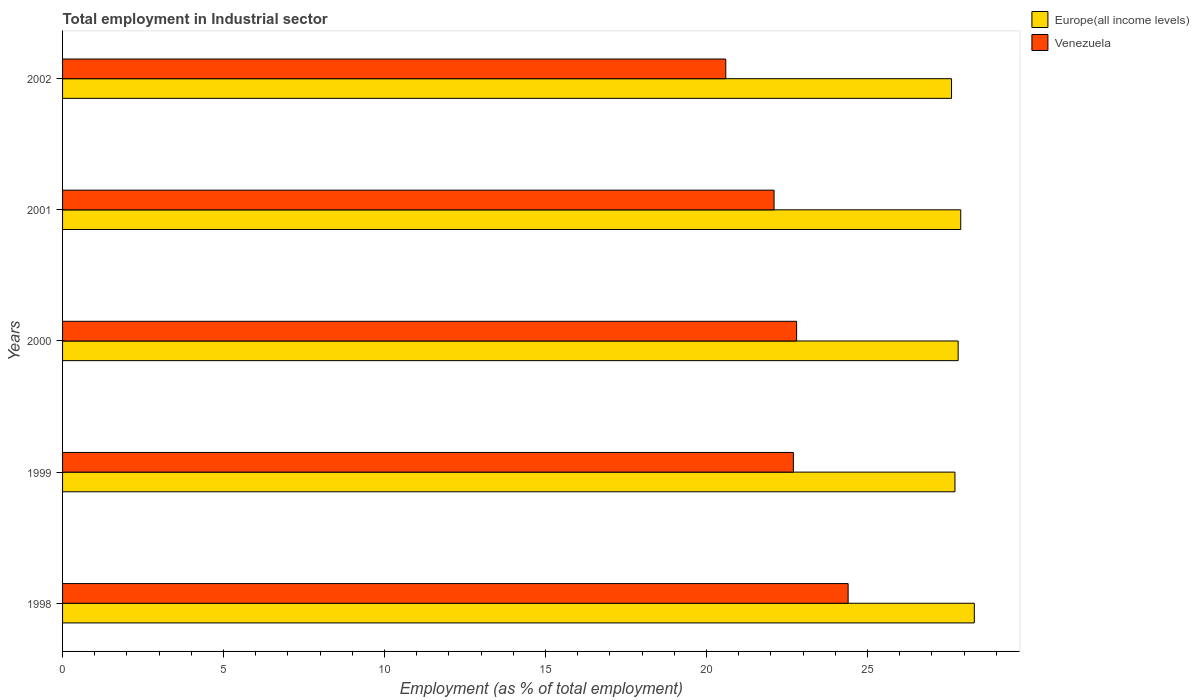Are the number of bars per tick equal to the number of legend labels?
Give a very brief answer. Yes. Are the number of bars on each tick of the Y-axis equal?
Your answer should be very brief. Yes. What is the label of the 1st group of bars from the top?
Ensure brevity in your answer.  2002. In how many cases, is the number of bars for a given year not equal to the number of legend labels?
Provide a succinct answer. 0. What is the employment in industrial sector in Europe(all income levels) in 2002?
Keep it short and to the point. 27.61. Across all years, what is the maximum employment in industrial sector in Venezuela?
Provide a succinct answer. 24.4. Across all years, what is the minimum employment in industrial sector in Venezuela?
Provide a short and direct response. 20.6. What is the total employment in industrial sector in Europe(all income levels) in the graph?
Your response must be concise. 139.37. What is the difference between the employment in industrial sector in Venezuela in 2000 and that in 2001?
Provide a short and direct response. 0.7. What is the difference between the employment in industrial sector in Venezuela in 1999 and the employment in industrial sector in Europe(all income levels) in 2002?
Ensure brevity in your answer.  -4.91. What is the average employment in industrial sector in Europe(all income levels) per year?
Keep it short and to the point. 27.87. In the year 1998, what is the difference between the employment in industrial sector in Venezuela and employment in industrial sector in Europe(all income levels)?
Provide a short and direct response. -3.92. What is the ratio of the employment in industrial sector in Venezuela in 1998 to that in 2000?
Provide a short and direct response. 1.07. Is the difference between the employment in industrial sector in Venezuela in 1999 and 2001 greater than the difference between the employment in industrial sector in Europe(all income levels) in 1999 and 2001?
Your answer should be compact. Yes. What is the difference between the highest and the second highest employment in industrial sector in Europe(all income levels)?
Offer a very short reply. 0.42. What is the difference between the highest and the lowest employment in industrial sector in Europe(all income levels)?
Make the answer very short. 0.71. What does the 1st bar from the top in 1999 represents?
Your response must be concise. Venezuela. What does the 1st bar from the bottom in 2000 represents?
Offer a terse response. Europe(all income levels). How many bars are there?
Offer a very short reply. 10. Are all the bars in the graph horizontal?
Your answer should be very brief. Yes. What is the difference between two consecutive major ticks on the X-axis?
Offer a very short reply. 5. Are the values on the major ticks of X-axis written in scientific E-notation?
Offer a terse response. No. Does the graph contain any zero values?
Ensure brevity in your answer.  No. What is the title of the graph?
Offer a very short reply. Total employment in Industrial sector. Does "Suriname" appear as one of the legend labels in the graph?
Give a very brief answer. No. What is the label or title of the X-axis?
Your answer should be compact. Employment (as % of total employment). What is the Employment (as % of total employment) in Europe(all income levels) in 1998?
Provide a short and direct response. 28.32. What is the Employment (as % of total employment) in Venezuela in 1998?
Make the answer very short. 24.4. What is the Employment (as % of total employment) of Europe(all income levels) in 1999?
Provide a short and direct response. 27.72. What is the Employment (as % of total employment) in Venezuela in 1999?
Make the answer very short. 22.7. What is the Employment (as % of total employment) in Europe(all income levels) in 2000?
Offer a very short reply. 27.82. What is the Employment (as % of total employment) of Venezuela in 2000?
Provide a succinct answer. 22.8. What is the Employment (as % of total employment) in Europe(all income levels) in 2001?
Give a very brief answer. 27.9. What is the Employment (as % of total employment) in Venezuela in 2001?
Ensure brevity in your answer.  22.1. What is the Employment (as % of total employment) of Europe(all income levels) in 2002?
Keep it short and to the point. 27.61. What is the Employment (as % of total employment) of Venezuela in 2002?
Give a very brief answer. 20.6. Across all years, what is the maximum Employment (as % of total employment) in Europe(all income levels)?
Your response must be concise. 28.32. Across all years, what is the maximum Employment (as % of total employment) in Venezuela?
Offer a terse response. 24.4. Across all years, what is the minimum Employment (as % of total employment) in Europe(all income levels)?
Provide a succinct answer. 27.61. Across all years, what is the minimum Employment (as % of total employment) in Venezuela?
Provide a succinct answer. 20.6. What is the total Employment (as % of total employment) in Europe(all income levels) in the graph?
Your answer should be compact. 139.37. What is the total Employment (as % of total employment) of Venezuela in the graph?
Offer a very short reply. 112.6. What is the difference between the Employment (as % of total employment) in Europe(all income levels) in 1998 and that in 1999?
Your answer should be compact. 0.6. What is the difference between the Employment (as % of total employment) in Venezuela in 1998 and that in 1999?
Make the answer very short. 1.7. What is the difference between the Employment (as % of total employment) in Europe(all income levels) in 1998 and that in 2000?
Offer a terse response. 0.5. What is the difference between the Employment (as % of total employment) of Venezuela in 1998 and that in 2000?
Offer a very short reply. 1.6. What is the difference between the Employment (as % of total employment) of Europe(all income levels) in 1998 and that in 2001?
Make the answer very short. 0.42. What is the difference between the Employment (as % of total employment) in Venezuela in 1998 and that in 2001?
Give a very brief answer. 2.3. What is the difference between the Employment (as % of total employment) in Europe(all income levels) in 1998 and that in 2002?
Make the answer very short. 0.71. What is the difference between the Employment (as % of total employment) in Venezuela in 1998 and that in 2002?
Offer a very short reply. 3.8. What is the difference between the Employment (as % of total employment) in Europe(all income levels) in 1999 and that in 2000?
Give a very brief answer. -0.1. What is the difference between the Employment (as % of total employment) in Venezuela in 1999 and that in 2000?
Offer a terse response. -0.1. What is the difference between the Employment (as % of total employment) in Europe(all income levels) in 1999 and that in 2001?
Ensure brevity in your answer.  -0.18. What is the difference between the Employment (as % of total employment) of Venezuela in 1999 and that in 2001?
Your answer should be compact. 0.6. What is the difference between the Employment (as % of total employment) in Europe(all income levels) in 1999 and that in 2002?
Give a very brief answer. 0.11. What is the difference between the Employment (as % of total employment) in Europe(all income levels) in 2000 and that in 2001?
Provide a succinct answer. -0.08. What is the difference between the Employment (as % of total employment) of Venezuela in 2000 and that in 2001?
Provide a succinct answer. 0.7. What is the difference between the Employment (as % of total employment) in Europe(all income levels) in 2000 and that in 2002?
Offer a very short reply. 0.21. What is the difference between the Employment (as % of total employment) of Venezuela in 2000 and that in 2002?
Ensure brevity in your answer.  2.2. What is the difference between the Employment (as % of total employment) of Europe(all income levels) in 2001 and that in 2002?
Ensure brevity in your answer.  0.29. What is the difference between the Employment (as % of total employment) of Venezuela in 2001 and that in 2002?
Keep it short and to the point. 1.5. What is the difference between the Employment (as % of total employment) in Europe(all income levels) in 1998 and the Employment (as % of total employment) in Venezuela in 1999?
Keep it short and to the point. 5.62. What is the difference between the Employment (as % of total employment) in Europe(all income levels) in 1998 and the Employment (as % of total employment) in Venezuela in 2000?
Give a very brief answer. 5.52. What is the difference between the Employment (as % of total employment) in Europe(all income levels) in 1998 and the Employment (as % of total employment) in Venezuela in 2001?
Make the answer very short. 6.22. What is the difference between the Employment (as % of total employment) in Europe(all income levels) in 1998 and the Employment (as % of total employment) in Venezuela in 2002?
Offer a terse response. 7.72. What is the difference between the Employment (as % of total employment) of Europe(all income levels) in 1999 and the Employment (as % of total employment) of Venezuela in 2000?
Keep it short and to the point. 4.92. What is the difference between the Employment (as % of total employment) in Europe(all income levels) in 1999 and the Employment (as % of total employment) in Venezuela in 2001?
Provide a succinct answer. 5.62. What is the difference between the Employment (as % of total employment) of Europe(all income levels) in 1999 and the Employment (as % of total employment) of Venezuela in 2002?
Give a very brief answer. 7.12. What is the difference between the Employment (as % of total employment) of Europe(all income levels) in 2000 and the Employment (as % of total employment) of Venezuela in 2001?
Offer a terse response. 5.72. What is the difference between the Employment (as % of total employment) in Europe(all income levels) in 2000 and the Employment (as % of total employment) in Venezuela in 2002?
Your answer should be very brief. 7.22. What is the difference between the Employment (as % of total employment) in Europe(all income levels) in 2001 and the Employment (as % of total employment) in Venezuela in 2002?
Give a very brief answer. 7.3. What is the average Employment (as % of total employment) of Europe(all income levels) per year?
Offer a terse response. 27.87. What is the average Employment (as % of total employment) in Venezuela per year?
Offer a very short reply. 22.52. In the year 1998, what is the difference between the Employment (as % of total employment) of Europe(all income levels) and Employment (as % of total employment) of Venezuela?
Keep it short and to the point. 3.92. In the year 1999, what is the difference between the Employment (as % of total employment) in Europe(all income levels) and Employment (as % of total employment) in Venezuela?
Give a very brief answer. 5.02. In the year 2000, what is the difference between the Employment (as % of total employment) in Europe(all income levels) and Employment (as % of total employment) in Venezuela?
Your answer should be compact. 5.02. In the year 2001, what is the difference between the Employment (as % of total employment) of Europe(all income levels) and Employment (as % of total employment) of Venezuela?
Provide a short and direct response. 5.8. In the year 2002, what is the difference between the Employment (as % of total employment) of Europe(all income levels) and Employment (as % of total employment) of Venezuela?
Make the answer very short. 7.01. What is the ratio of the Employment (as % of total employment) in Europe(all income levels) in 1998 to that in 1999?
Provide a succinct answer. 1.02. What is the ratio of the Employment (as % of total employment) of Venezuela in 1998 to that in 1999?
Ensure brevity in your answer.  1.07. What is the ratio of the Employment (as % of total employment) of Europe(all income levels) in 1998 to that in 2000?
Ensure brevity in your answer.  1.02. What is the ratio of the Employment (as % of total employment) of Venezuela in 1998 to that in 2000?
Offer a terse response. 1.07. What is the ratio of the Employment (as % of total employment) of Europe(all income levels) in 1998 to that in 2001?
Provide a short and direct response. 1.02. What is the ratio of the Employment (as % of total employment) in Venezuela in 1998 to that in 2001?
Offer a very short reply. 1.1. What is the ratio of the Employment (as % of total employment) in Europe(all income levels) in 1998 to that in 2002?
Your response must be concise. 1.03. What is the ratio of the Employment (as % of total employment) in Venezuela in 1998 to that in 2002?
Your answer should be very brief. 1.18. What is the ratio of the Employment (as % of total employment) in Europe(all income levels) in 1999 to that in 2000?
Make the answer very short. 1. What is the ratio of the Employment (as % of total employment) of Venezuela in 1999 to that in 2001?
Provide a succinct answer. 1.03. What is the ratio of the Employment (as % of total employment) in Venezuela in 1999 to that in 2002?
Your answer should be compact. 1.1. What is the ratio of the Employment (as % of total employment) in Europe(all income levels) in 2000 to that in 2001?
Give a very brief answer. 1. What is the ratio of the Employment (as % of total employment) in Venezuela in 2000 to that in 2001?
Your answer should be compact. 1.03. What is the ratio of the Employment (as % of total employment) of Europe(all income levels) in 2000 to that in 2002?
Provide a short and direct response. 1.01. What is the ratio of the Employment (as % of total employment) in Venezuela in 2000 to that in 2002?
Your response must be concise. 1.11. What is the ratio of the Employment (as % of total employment) in Europe(all income levels) in 2001 to that in 2002?
Ensure brevity in your answer.  1.01. What is the ratio of the Employment (as % of total employment) in Venezuela in 2001 to that in 2002?
Your answer should be very brief. 1.07. What is the difference between the highest and the second highest Employment (as % of total employment) in Europe(all income levels)?
Keep it short and to the point. 0.42. What is the difference between the highest and the second highest Employment (as % of total employment) in Venezuela?
Your answer should be very brief. 1.6. What is the difference between the highest and the lowest Employment (as % of total employment) in Europe(all income levels)?
Your response must be concise. 0.71. What is the difference between the highest and the lowest Employment (as % of total employment) of Venezuela?
Your response must be concise. 3.8. 